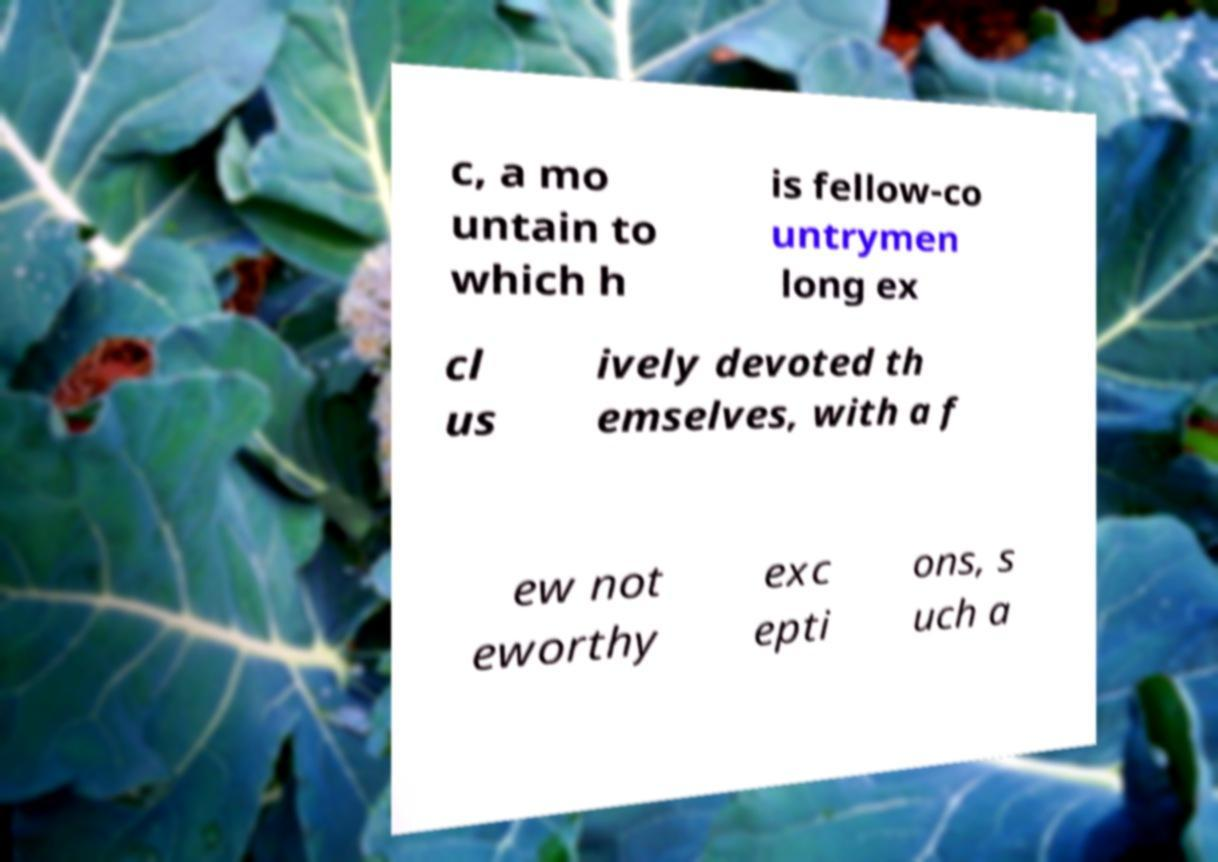Could you extract and type out the text from this image? c, a mo untain to which h is fellow-co untrymen long ex cl us ively devoted th emselves, with a f ew not eworthy exc epti ons, s uch a 